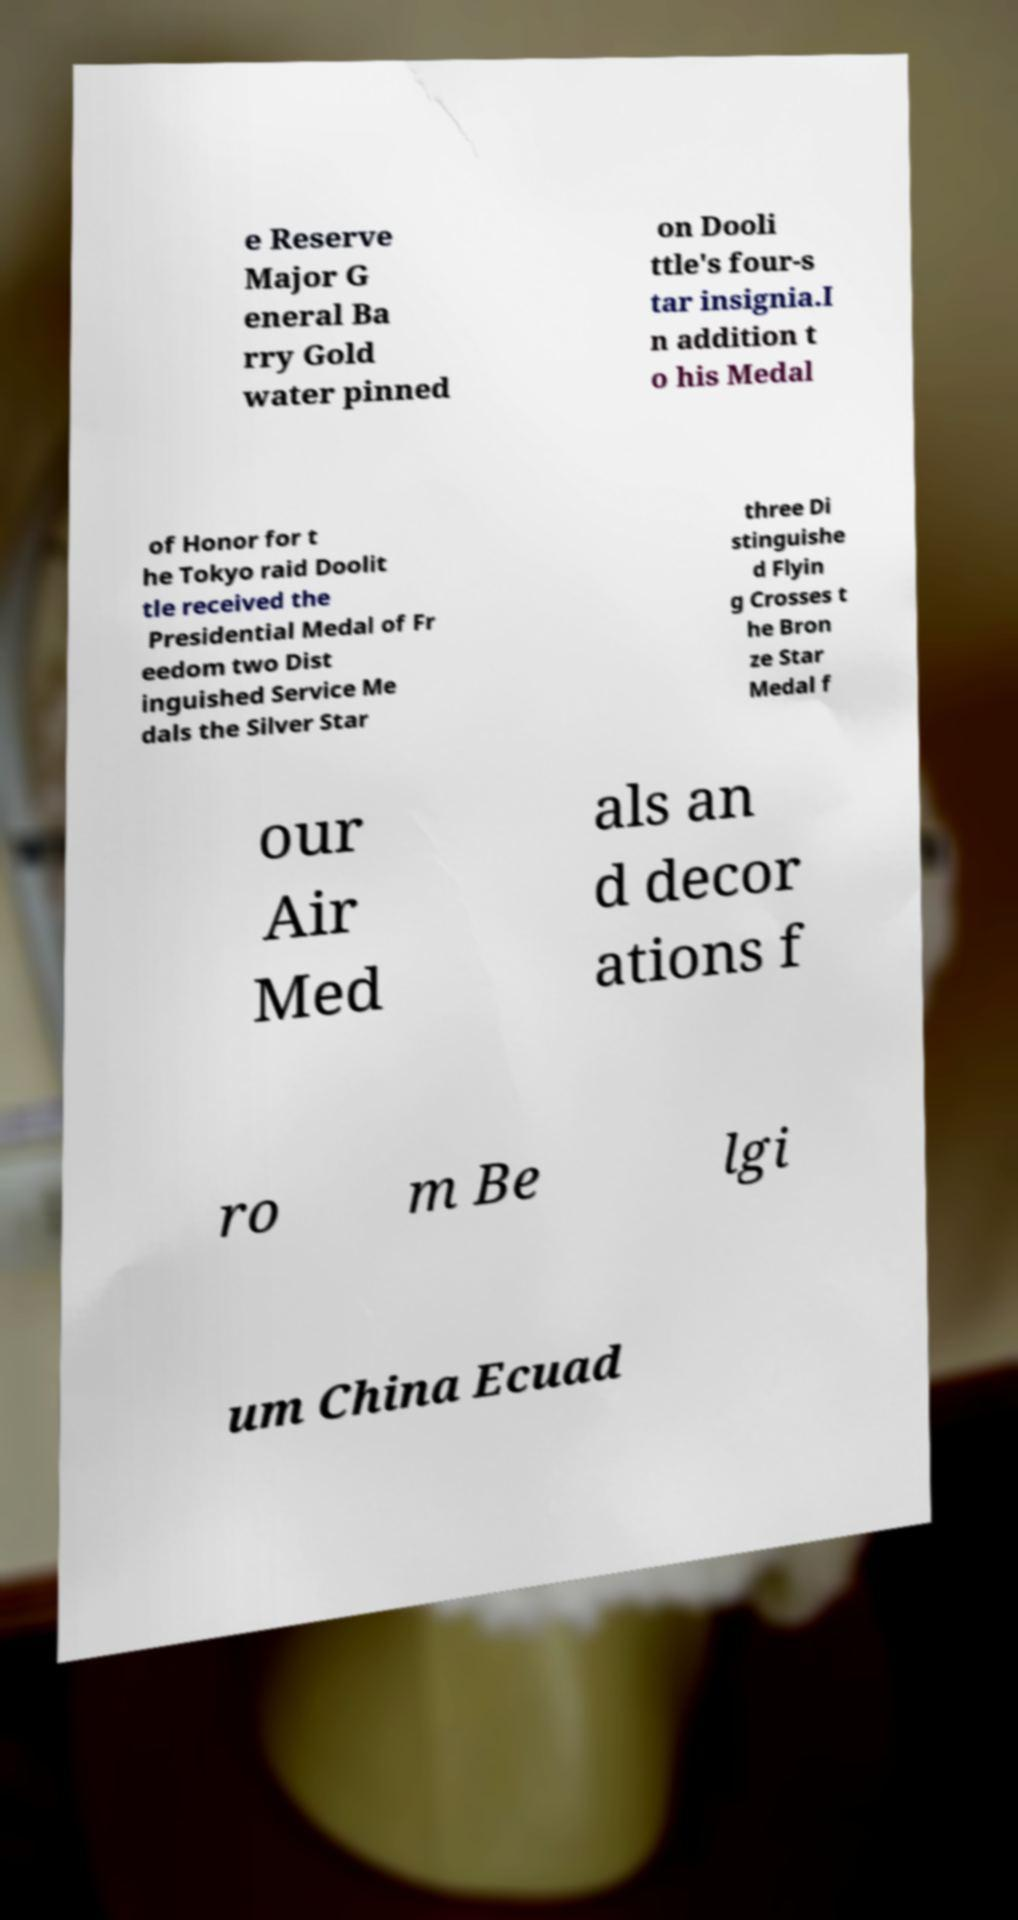Could you extract and type out the text from this image? e Reserve Major G eneral Ba rry Gold water pinned on Dooli ttle's four-s tar insignia.I n addition t o his Medal of Honor for t he Tokyo raid Doolit tle received the Presidential Medal of Fr eedom two Dist inguished Service Me dals the Silver Star three Di stinguishe d Flyin g Crosses t he Bron ze Star Medal f our Air Med als an d decor ations f ro m Be lgi um China Ecuad 